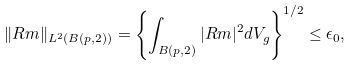<formula> <loc_0><loc_0><loc_500><loc_500>\| R m \| _ { L ^ { 2 } ( B ( p , 2 ) ) } = \left \{ \int _ { B ( p , 2 ) } | R m | ^ { 2 } d V _ { g } \right \} ^ { 1 / 2 } \leq \epsilon _ { 0 } ,</formula> 